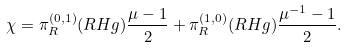Convert formula to latex. <formula><loc_0><loc_0><loc_500><loc_500>\chi = \pi ^ { ( 0 , 1 ) } _ { R } ( R H g ) \frac { \mu - 1 } 2 + \pi ^ { ( 1 , 0 ) } _ { R } ( R H g ) \frac { \mu ^ { - 1 } - 1 } 2 .</formula> 